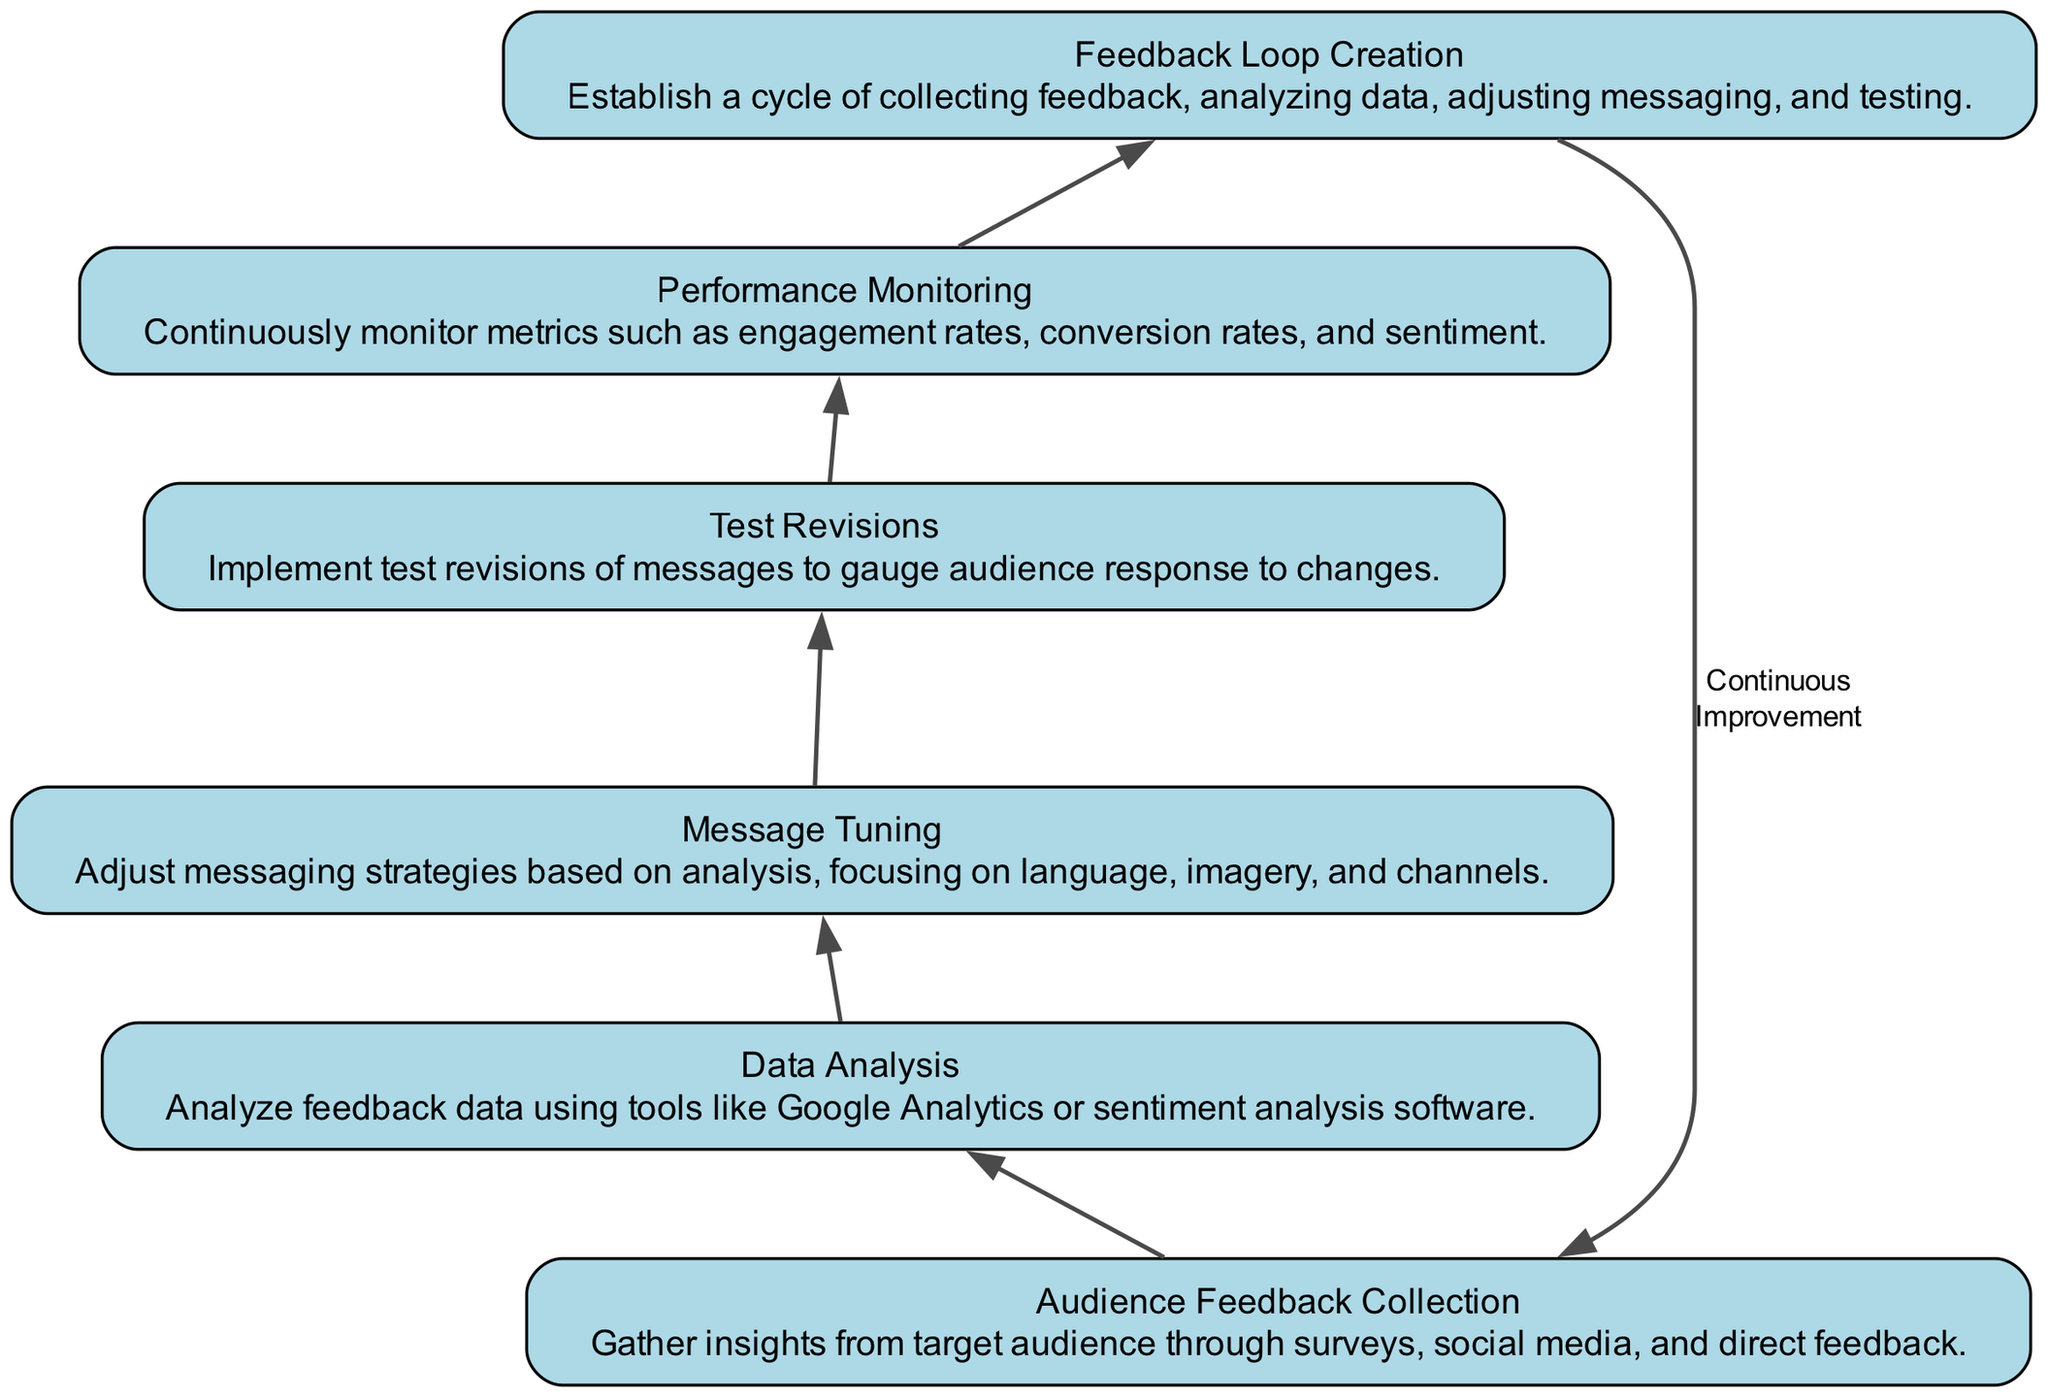What is the first step in the feedback loop? The first step in the feedback loop is "Audience Feedback Collection," which gathers insights from the target audience.
Answer: Audience Feedback Collection How many nodes are in the diagram? By counting all the rectangular nodes listed, there are six nodes in total in the diagram.
Answer: 6 What action follows performance monitoring? After performance monitoring, the next action is "Feedback Loop Creation," which completes the cycle.
Answer: Feedback Loop Creation What is the relationship between message tuning and test revisions? The relationship is direct; "Test Revisions" follows "Message Tuning," indicating a sequential action based on adjustments made to messaging.
Answer: Sequential Which element involves the use of tools like Google Analytics? The element that involves the use of tools like Google Analytics is "Data Analysis," as it specifically analyzes the collected feedback data.
Answer: Data Analysis What does the feedback loop signify in the diagram? The feedback loop signifies "Continuous Improvement," indicating that the process repeats itself to refine messaging based on audience response.
Answer: Continuous Improvement How is audience response gauged according to the diagram? Audience response is gauged through "Test Revisions," which implements changes to messages and assesses the reaction from the audience.
Answer: Test Revisions Which stage of the process focuses on analyzing data received? The stage that focuses on analyzing the received data is "Data Analysis," which is crucial for interpreting feedback effectively.
Answer: Data Analysis 